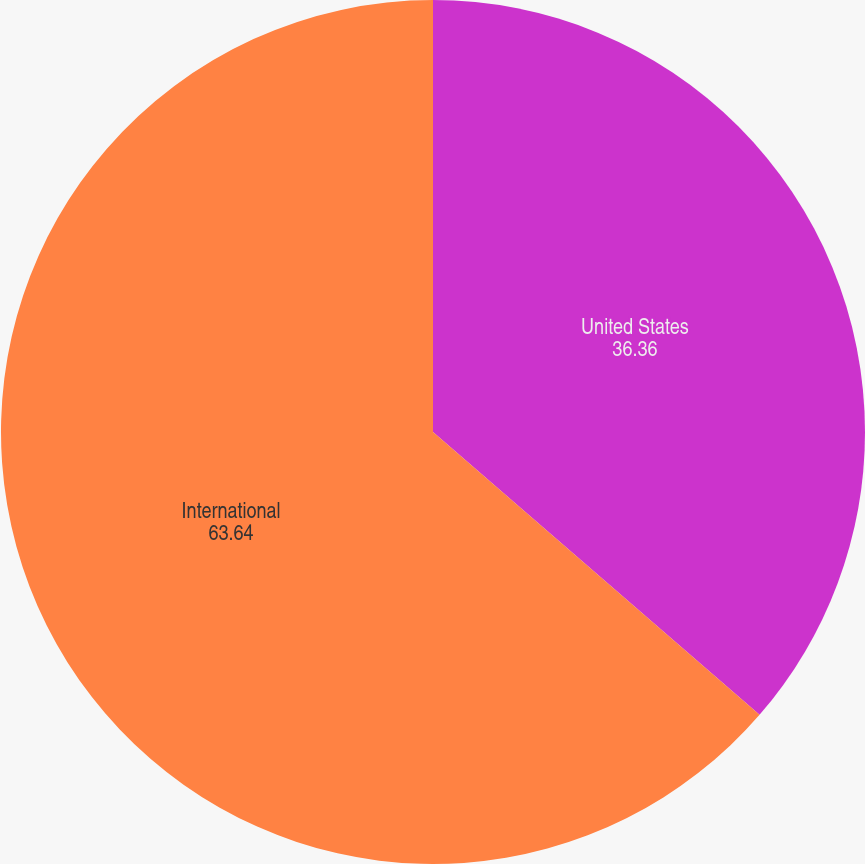Convert chart to OTSL. <chart><loc_0><loc_0><loc_500><loc_500><pie_chart><fcel>United States<fcel>International<nl><fcel>36.36%<fcel>63.64%<nl></chart> 